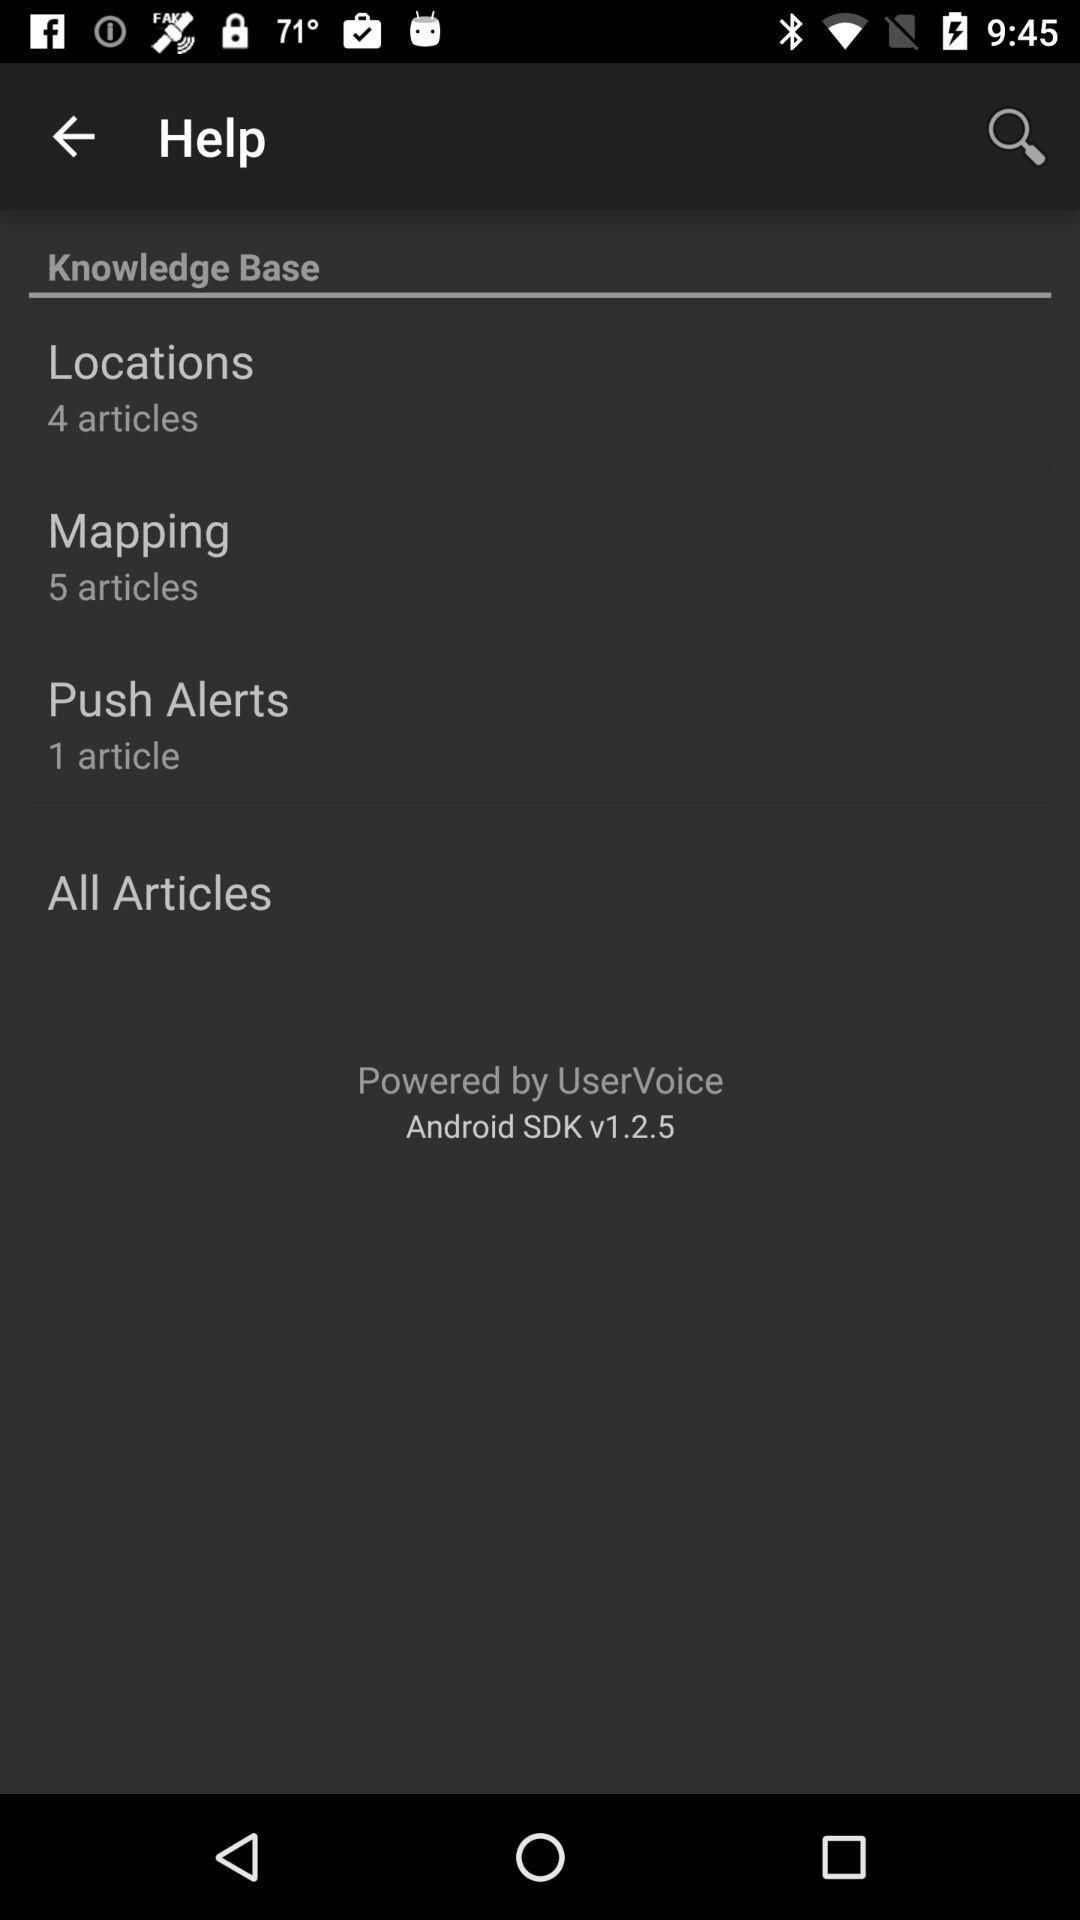How many articles are there in the Mapping section?
Answer the question using a single word or phrase. 5 